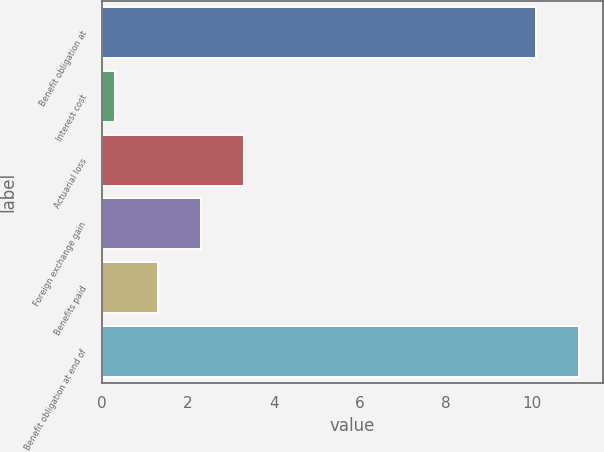Convert chart. <chart><loc_0><loc_0><loc_500><loc_500><bar_chart><fcel>Benefit obligation at<fcel>Interest cost<fcel>Actuarial loss<fcel>Foreign exchange gain<fcel>Benefits paid<fcel>Benefit obligation at end of<nl><fcel>10.1<fcel>0.3<fcel>3.3<fcel>2.3<fcel>1.3<fcel>11.1<nl></chart> 